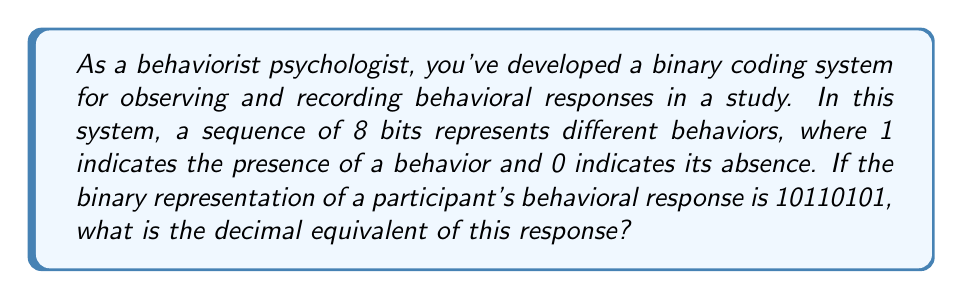Teach me how to tackle this problem. To convert a binary number to its decimal equivalent, we can use the following method:

1. Write out the binary number: 10110101
2. Number each digit from right to left, starting with 0: 
   $$10110101_2 = 1\cdot2^7 + 0\cdot2^6 + 1\cdot2^5 + 1\cdot2^4 + 0\cdot2^3 + 1\cdot2^2 + 0\cdot2^1 + 1\cdot2^0$$

3. Calculate each term:
   $$1\cdot2^7 = 1\cdot128 = 128$$
   $$0\cdot2^6 = 0\cdot64 = 0$$
   $$1\cdot2^5 = 1\cdot32 = 32$$
   $$1\cdot2^4 = 1\cdot16 = 16$$
   $$0\cdot2^3 = 0\cdot8 = 0$$
   $$1\cdot2^2 = 1\cdot4 = 4$$
   $$0\cdot2^1 = 0\cdot2 = 0$$
   $$1\cdot2^0 = 1\cdot1 = 1$$

4. Sum all the calculated terms:
   $$128 + 0 + 32 + 16 + 0 + 4 + 0 + 1 = 181$$

Therefore, the decimal equivalent of the binary number 10110101 is 181.

In the context of behaviorism, this decimal number could represent a unique combination of observed behaviors, allowing for quantitative analysis of complex behavioral patterns.
Answer: 181 